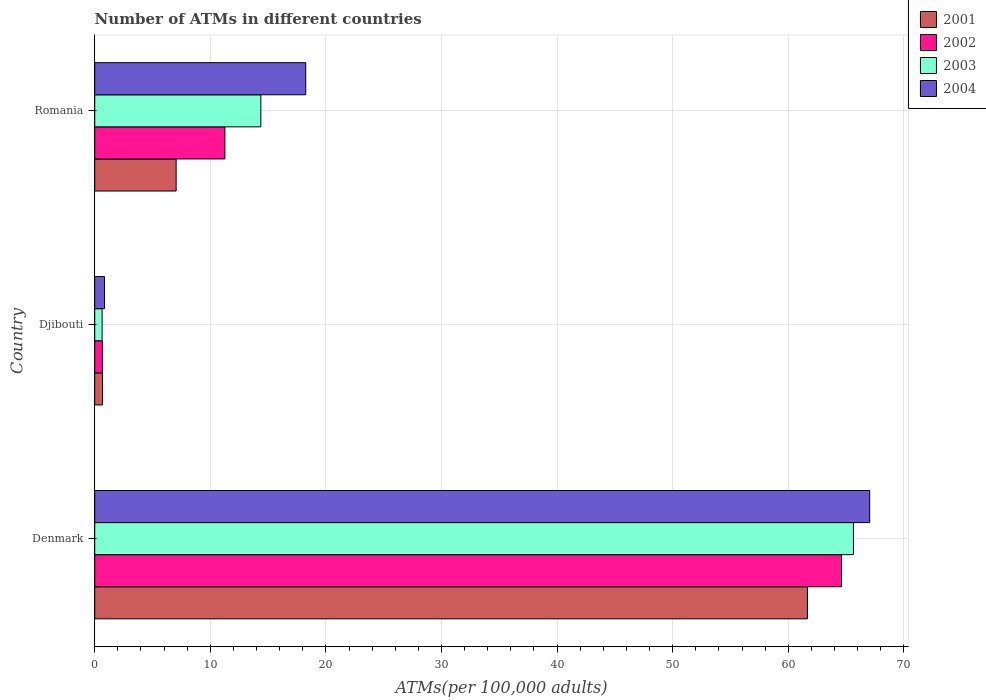How many different coloured bars are there?
Provide a short and direct response. 4. How many groups of bars are there?
Keep it short and to the point. 3. Are the number of bars per tick equal to the number of legend labels?
Your answer should be compact. Yes. Are the number of bars on each tick of the Y-axis equal?
Keep it short and to the point. Yes. How many bars are there on the 2nd tick from the bottom?
Offer a terse response. 4. What is the label of the 1st group of bars from the top?
Your answer should be very brief. Romania. In how many cases, is the number of bars for a given country not equal to the number of legend labels?
Ensure brevity in your answer.  0. What is the number of ATMs in 2004 in Denmark?
Your answer should be very brief. 67.04. Across all countries, what is the maximum number of ATMs in 2001?
Ensure brevity in your answer.  61.66. Across all countries, what is the minimum number of ATMs in 2001?
Your answer should be compact. 0.68. In which country was the number of ATMs in 2004 maximum?
Your answer should be compact. Denmark. In which country was the number of ATMs in 2001 minimum?
Your response must be concise. Djibouti. What is the total number of ATMs in 2003 in the graph?
Your response must be concise. 80.65. What is the difference between the number of ATMs in 2001 in Denmark and that in Romania?
Offer a terse response. 54.61. What is the difference between the number of ATMs in 2002 in Romania and the number of ATMs in 2001 in Djibouti?
Provide a short and direct response. 10.58. What is the average number of ATMs in 2002 per country?
Ensure brevity in your answer.  25.51. What is the difference between the number of ATMs in 2002 and number of ATMs in 2004 in Denmark?
Provide a succinct answer. -2.44. What is the ratio of the number of ATMs in 2002 in Djibouti to that in Romania?
Ensure brevity in your answer.  0.06. Is the number of ATMs in 2003 in Djibouti less than that in Romania?
Keep it short and to the point. Yes. Is the difference between the number of ATMs in 2002 in Djibouti and Romania greater than the difference between the number of ATMs in 2004 in Djibouti and Romania?
Provide a succinct answer. Yes. What is the difference between the highest and the second highest number of ATMs in 2004?
Keep it short and to the point. 48.79. What is the difference between the highest and the lowest number of ATMs in 2002?
Your answer should be very brief. 63.95. In how many countries, is the number of ATMs in 2001 greater than the average number of ATMs in 2001 taken over all countries?
Your answer should be compact. 1. Is the sum of the number of ATMs in 2004 in Djibouti and Romania greater than the maximum number of ATMs in 2001 across all countries?
Provide a succinct answer. No. Is it the case that in every country, the sum of the number of ATMs in 2001 and number of ATMs in 2003 is greater than the sum of number of ATMs in 2004 and number of ATMs in 2002?
Provide a short and direct response. No. What does the 3rd bar from the bottom in Romania represents?
Offer a terse response. 2003. How many countries are there in the graph?
Offer a very short reply. 3. Are the values on the major ticks of X-axis written in scientific E-notation?
Your answer should be very brief. No. How are the legend labels stacked?
Your response must be concise. Vertical. What is the title of the graph?
Ensure brevity in your answer.  Number of ATMs in different countries. What is the label or title of the X-axis?
Provide a succinct answer. ATMs(per 100,0 adults). What is the ATMs(per 100,000 adults) in 2001 in Denmark?
Your answer should be very brief. 61.66. What is the ATMs(per 100,000 adults) of 2002 in Denmark?
Keep it short and to the point. 64.61. What is the ATMs(per 100,000 adults) in 2003 in Denmark?
Keep it short and to the point. 65.64. What is the ATMs(per 100,000 adults) of 2004 in Denmark?
Offer a terse response. 67.04. What is the ATMs(per 100,000 adults) in 2001 in Djibouti?
Provide a short and direct response. 0.68. What is the ATMs(per 100,000 adults) of 2002 in Djibouti?
Your answer should be compact. 0.66. What is the ATMs(per 100,000 adults) of 2003 in Djibouti?
Give a very brief answer. 0.64. What is the ATMs(per 100,000 adults) in 2004 in Djibouti?
Your answer should be compact. 0.84. What is the ATMs(per 100,000 adults) in 2001 in Romania?
Your answer should be very brief. 7.04. What is the ATMs(per 100,000 adults) in 2002 in Romania?
Ensure brevity in your answer.  11.26. What is the ATMs(per 100,000 adults) in 2003 in Romania?
Provide a succinct answer. 14.37. What is the ATMs(per 100,000 adults) in 2004 in Romania?
Make the answer very short. 18.26. Across all countries, what is the maximum ATMs(per 100,000 adults) of 2001?
Provide a succinct answer. 61.66. Across all countries, what is the maximum ATMs(per 100,000 adults) of 2002?
Your answer should be compact. 64.61. Across all countries, what is the maximum ATMs(per 100,000 adults) in 2003?
Provide a short and direct response. 65.64. Across all countries, what is the maximum ATMs(per 100,000 adults) in 2004?
Your answer should be compact. 67.04. Across all countries, what is the minimum ATMs(per 100,000 adults) in 2001?
Provide a succinct answer. 0.68. Across all countries, what is the minimum ATMs(per 100,000 adults) in 2002?
Ensure brevity in your answer.  0.66. Across all countries, what is the minimum ATMs(per 100,000 adults) in 2003?
Offer a terse response. 0.64. Across all countries, what is the minimum ATMs(per 100,000 adults) in 2004?
Your response must be concise. 0.84. What is the total ATMs(per 100,000 adults) of 2001 in the graph?
Keep it short and to the point. 69.38. What is the total ATMs(per 100,000 adults) in 2002 in the graph?
Keep it short and to the point. 76.52. What is the total ATMs(per 100,000 adults) in 2003 in the graph?
Provide a succinct answer. 80.65. What is the total ATMs(per 100,000 adults) of 2004 in the graph?
Your response must be concise. 86.14. What is the difference between the ATMs(per 100,000 adults) of 2001 in Denmark and that in Djibouti?
Provide a short and direct response. 60.98. What is the difference between the ATMs(per 100,000 adults) in 2002 in Denmark and that in Djibouti?
Your answer should be compact. 63.95. What is the difference between the ATMs(per 100,000 adults) in 2003 in Denmark and that in Djibouti?
Offer a terse response. 65. What is the difference between the ATMs(per 100,000 adults) in 2004 in Denmark and that in Djibouti?
Provide a succinct answer. 66.2. What is the difference between the ATMs(per 100,000 adults) of 2001 in Denmark and that in Romania?
Provide a short and direct response. 54.61. What is the difference between the ATMs(per 100,000 adults) in 2002 in Denmark and that in Romania?
Your answer should be very brief. 53.35. What is the difference between the ATMs(per 100,000 adults) of 2003 in Denmark and that in Romania?
Your response must be concise. 51.27. What is the difference between the ATMs(per 100,000 adults) in 2004 in Denmark and that in Romania?
Your answer should be very brief. 48.79. What is the difference between the ATMs(per 100,000 adults) of 2001 in Djibouti and that in Romania?
Make the answer very short. -6.37. What is the difference between the ATMs(per 100,000 adults) of 2002 in Djibouti and that in Romania?
Your answer should be compact. -10.6. What is the difference between the ATMs(per 100,000 adults) in 2003 in Djibouti and that in Romania?
Your response must be concise. -13.73. What is the difference between the ATMs(per 100,000 adults) in 2004 in Djibouti and that in Romania?
Make the answer very short. -17.41. What is the difference between the ATMs(per 100,000 adults) of 2001 in Denmark and the ATMs(per 100,000 adults) of 2002 in Djibouti?
Ensure brevity in your answer.  61. What is the difference between the ATMs(per 100,000 adults) of 2001 in Denmark and the ATMs(per 100,000 adults) of 2003 in Djibouti?
Your response must be concise. 61.02. What is the difference between the ATMs(per 100,000 adults) of 2001 in Denmark and the ATMs(per 100,000 adults) of 2004 in Djibouti?
Your response must be concise. 60.81. What is the difference between the ATMs(per 100,000 adults) in 2002 in Denmark and the ATMs(per 100,000 adults) in 2003 in Djibouti?
Provide a short and direct response. 63.97. What is the difference between the ATMs(per 100,000 adults) in 2002 in Denmark and the ATMs(per 100,000 adults) in 2004 in Djibouti?
Provide a succinct answer. 63.76. What is the difference between the ATMs(per 100,000 adults) of 2003 in Denmark and the ATMs(per 100,000 adults) of 2004 in Djibouti?
Provide a short and direct response. 64.79. What is the difference between the ATMs(per 100,000 adults) in 2001 in Denmark and the ATMs(per 100,000 adults) in 2002 in Romania?
Ensure brevity in your answer.  50.4. What is the difference between the ATMs(per 100,000 adults) in 2001 in Denmark and the ATMs(per 100,000 adults) in 2003 in Romania?
Your answer should be very brief. 47.29. What is the difference between the ATMs(per 100,000 adults) of 2001 in Denmark and the ATMs(per 100,000 adults) of 2004 in Romania?
Ensure brevity in your answer.  43.4. What is the difference between the ATMs(per 100,000 adults) in 2002 in Denmark and the ATMs(per 100,000 adults) in 2003 in Romania?
Ensure brevity in your answer.  50.24. What is the difference between the ATMs(per 100,000 adults) in 2002 in Denmark and the ATMs(per 100,000 adults) in 2004 in Romania?
Ensure brevity in your answer.  46.35. What is the difference between the ATMs(per 100,000 adults) of 2003 in Denmark and the ATMs(per 100,000 adults) of 2004 in Romania?
Your response must be concise. 47.38. What is the difference between the ATMs(per 100,000 adults) of 2001 in Djibouti and the ATMs(per 100,000 adults) of 2002 in Romania?
Make the answer very short. -10.58. What is the difference between the ATMs(per 100,000 adults) of 2001 in Djibouti and the ATMs(per 100,000 adults) of 2003 in Romania?
Offer a terse response. -13.69. What is the difference between the ATMs(per 100,000 adults) of 2001 in Djibouti and the ATMs(per 100,000 adults) of 2004 in Romania?
Keep it short and to the point. -17.58. What is the difference between the ATMs(per 100,000 adults) of 2002 in Djibouti and the ATMs(per 100,000 adults) of 2003 in Romania?
Ensure brevity in your answer.  -13.71. What is the difference between the ATMs(per 100,000 adults) of 2002 in Djibouti and the ATMs(per 100,000 adults) of 2004 in Romania?
Provide a short and direct response. -17.6. What is the difference between the ATMs(per 100,000 adults) of 2003 in Djibouti and the ATMs(per 100,000 adults) of 2004 in Romania?
Keep it short and to the point. -17.62. What is the average ATMs(per 100,000 adults) of 2001 per country?
Provide a succinct answer. 23.13. What is the average ATMs(per 100,000 adults) of 2002 per country?
Give a very brief answer. 25.51. What is the average ATMs(per 100,000 adults) in 2003 per country?
Your answer should be very brief. 26.88. What is the average ATMs(per 100,000 adults) in 2004 per country?
Your answer should be very brief. 28.71. What is the difference between the ATMs(per 100,000 adults) of 2001 and ATMs(per 100,000 adults) of 2002 in Denmark?
Keep it short and to the point. -2.95. What is the difference between the ATMs(per 100,000 adults) of 2001 and ATMs(per 100,000 adults) of 2003 in Denmark?
Your answer should be compact. -3.98. What is the difference between the ATMs(per 100,000 adults) of 2001 and ATMs(per 100,000 adults) of 2004 in Denmark?
Give a very brief answer. -5.39. What is the difference between the ATMs(per 100,000 adults) in 2002 and ATMs(per 100,000 adults) in 2003 in Denmark?
Your answer should be very brief. -1.03. What is the difference between the ATMs(per 100,000 adults) in 2002 and ATMs(per 100,000 adults) in 2004 in Denmark?
Give a very brief answer. -2.44. What is the difference between the ATMs(per 100,000 adults) in 2003 and ATMs(per 100,000 adults) in 2004 in Denmark?
Ensure brevity in your answer.  -1.41. What is the difference between the ATMs(per 100,000 adults) of 2001 and ATMs(per 100,000 adults) of 2002 in Djibouti?
Provide a short and direct response. 0.02. What is the difference between the ATMs(per 100,000 adults) in 2001 and ATMs(per 100,000 adults) in 2003 in Djibouti?
Your response must be concise. 0.04. What is the difference between the ATMs(per 100,000 adults) of 2001 and ATMs(per 100,000 adults) of 2004 in Djibouti?
Keep it short and to the point. -0.17. What is the difference between the ATMs(per 100,000 adults) in 2002 and ATMs(per 100,000 adults) in 2003 in Djibouti?
Your answer should be very brief. 0.02. What is the difference between the ATMs(per 100,000 adults) of 2002 and ATMs(per 100,000 adults) of 2004 in Djibouti?
Ensure brevity in your answer.  -0.19. What is the difference between the ATMs(per 100,000 adults) in 2003 and ATMs(per 100,000 adults) in 2004 in Djibouti?
Keep it short and to the point. -0.21. What is the difference between the ATMs(per 100,000 adults) of 2001 and ATMs(per 100,000 adults) of 2002 in Romania?
Ensure brevity in your answer.  -4.21. What is the difference between the ATMs(per 100,000 adults) of 2001 and ATMs(per 100,000 adults) of 2003 in Romania?
Provide a succinct answer. -7.32. What is the difference between the ATMs(per 100,000 adults) in 2001 and ATMs(per 100,000 adults) in 2004 in Romania?
Ensure brevity in your answer.  -11.21. What is the difference between the ATMs(per 100,000 adults) in 2002 and ATMs(per 100,000 adults) in 2003 in Romania?
Keep it short and to the point. -3.11. What is the difference between the ATMs(per 100,000 adults) of 2002 and ATMs(per 100,000 adults) of 2004 in Romania?
Offer a terse response. -7. What is the difference between the ATMs(per 100,000 adults) in 2003 and ATMs(per 100,000 adults) in 2004 in Romania?
Your answer should be very brief. -3.89. What is the ratio of the ATMs(per 100,000 adults) in 2001 in Denmark to that in Djibouti?
Your response must be concise. 91.18. What is the ratio of the ATMs(per 100,000 adults) of 2002 in Denmark to that in Djibouti?
Ensure brevity in your answer.  98.45. What is the ratio of the ATMs(per 100,000 adults) in 2003 in Denmark to that in Djibouti?
Your response must be concise. 102.88. What is the ratio of the ATMs(per 100,000 adults) of 2004 in Denmark to that in Djibouti?
Offer a very short reply. 79.46. What is the ratio of the ATMs(per 100,000 adults) in 2001 in Denmark to that in Romania?
Provide a short and direct response. 8.75. What is the ratio of the ATMs(per 100,000 adults) of 2002 in Denmark to that in Romania?
Offer a very short reply. 5.74. What is the ratio of the ATMs(per 100,000 adults) of 2003 in Denmark to that in Romania?
Make the answer very short. 4.57. What is the ratio of the ATMs(per 100,000 adults) of 2004 in Denmark to that in Romania?
Your answer should be compact. 3.67. What is the ratio of the ATMs(per 100,000 adults) in 2001 in Djibouti to that in Romania?
Make the answer very short. 0.1. What is the ratio of the ATMs(per 100,000 adults) in 2002 in Djibouti to that in Romania?
Your answer should be very brief. 0.06. What is the ratio of the ATMs(per 100,000 adults) of 2003 in Djibouti to that in Romania?
Offer a terse response. 0.04. What is the ratio of the ATMs(per 100,000 adults) of 2004 in Djibouti to that in Romania?
Make the answer very short. 0.05. What is the difference between the highest and the second highest ATMs(per 100,000 adults) in 2001?
Your response must be concise. 54.61. What is the difference between the highest and the second highest ATMs(per 100,000 adults) of 2002?
Provide a succinct answer. 53.35. What is the difference between the highest and the second highest ATMs(per 100,000 adults) in 2003?
Your answer should be very brief. 51.27. What is the difference between the highest and the second highest ATMs(per 100,000 adults) of 2004?
Give a very brief answer. 48.79. What is the difference between the highest and the lowest ATMs(per 100,000 adults) of 2001?
Offer a very short reply. 60.98. What is the difference between the highest and the lowest ATMs(per 100,000 adults) of 2002?
Your response must be concise. 63.95. What is the difference between the highest and the lowest ATMs(per 100,000 adults) in 2003?
Make the answer very short. 65. What is the difference between the highest and the lowest ATMs(per 100,000 adults) of 2004?
Make the answer very short. 66.2. 